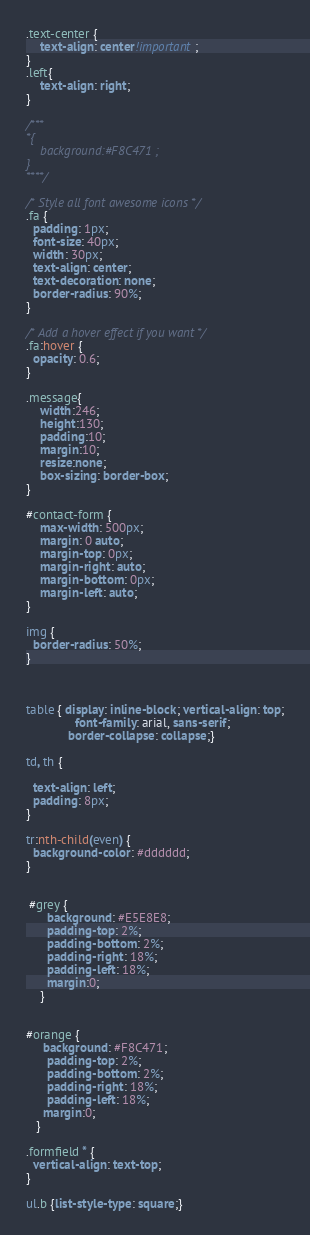Convert code to text. <code><loc_0><loc_0><loc_500><loc_500><_CSS_>.text-center {
    text-align: center!important;
}
.left{
    text-align: right;
}

/***
*{
    background:#F8C471 ;
}
****/

/* Style all font awesome icons */
.fa {
  padding: 1px;
  font-size: 40px;
  width: 30px;
  text-align: center;
  text-decoration: none;
  border-radius: 90%;
}

/* Add a hover effect if you want */
.fa:hover {
  opacity: 0.6;
}

.message{
    width:246;
    height:130;
    padding:10;
    margin:10;
    resize:none;
    box-sizing: border-box;
}

#contact-form {
    max-width: 500px;
    margin: 0 auto;
    margin-top: 0px;
    margin-right: auto;
    margin-bottom: 0px;
    margin-left: auto;
}

img {
  border-radius: 50%;
}



table { display: inline-block; vertical-align: top;
			  font-family: arial, sans-serif;
            border-collapse: collapse;}

td, th {

  text-align: left;
  padding: 8px;
}

tr:nth-child(even) {
  background-color: #dddddd;
}


 #grey {
      background: #E5E8E8;
      padding-top: 2%;
      padding-bottom: 2%;
      padding-right: 18%;
      padding-left: 18%;
      margin:0;
    }


#orange {
     background: #F8C471;
      padding-top: 2%;
      padding-bottom: 2%;
      padding-right: 18%;
      padding-left: 18%;
     margin:0;
   }

.formfield * {
  vertical-align: text-top;
}

ul.b {list-style-type: square;}</code> 